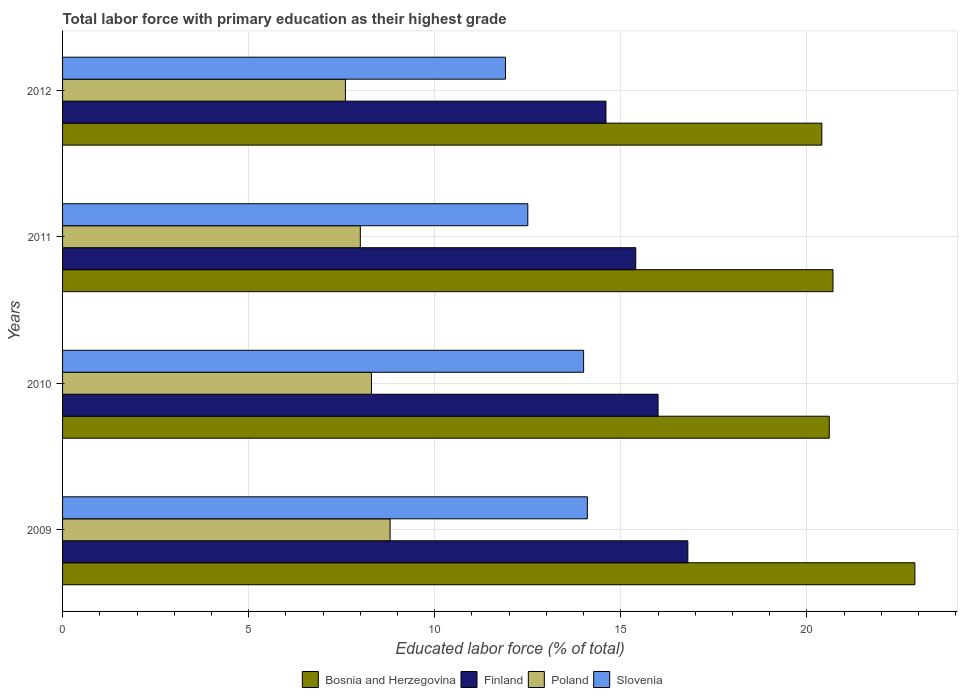Are the number of bars per tick equal to the number of legend labels?
Provide a succinct answer. Yes. What is the label of the 1st group of bars from the top?
Provide a short and direct response. 2012. In how many cases, is the number of bars for a given year not equal to the number of legend labels?
Your answer should be very brief. 0. Across all years, what is the maximum percentage of total labor force with primary education in Slovenia?
Give a very brief answer. 14.1. Across all years, what is the minimum percentage of total labor force with primary education in Bosnia and Herzegovina?
Ensure brevity in your answer.  20.4. In which year was the percentage of total labor force with primary education in Poland maximum?
Provide a short and direct response. 2009. What is the total percentage of total labor force with primary education in Finland in the graph?
Offer a very short reply. 62.8. What is the difference between the percentage of total labor force with primary education in Slovenia in 2009 and the percentage of total labor force with primary education in Finland in 2011?
Ensure brevity in your answer.  -1.3. What is the average percentage of total labor force with primary education in Slovenia per year?
Your response must be concise. 13.12. In the year 2012, what is the difference between the percentage of total labor force with primary education in Slovenia and percentage of total labor force with primary education in Bosnia and Herzegovina?
Offer a terse response. -8.5. In how many years, is the percentage of total labor force with primary education in Slovenia greater than 14 %?
Your response must be concise. 1. What is the ratio of the percentage of total labor force with primary education in Finland in 2009 to that in 2010?
Ensure brevity in your answer.  1.05. What is the difference between the highest and the second highest percentage of total labor force with primary education in Poland?
Ensure brevity in your answer.  0.5. What is the difference between the highest and the lowest percentage of total labor force with primary education in Poland?
Make the answer very short. 1.2. In how many years, is the percentage of total labor force with primary education in Bosnia and Herzegovina greater than the average percentage of total labor force with primary education in Bosnia and Herzegovina taken over all years?
Offer a very short reply. 1. Is it the case that in every year, the sum of the percentage of total labor force with primary education in Poland and percentage of total labor force with primary education in Bosnia and Herzegovina is greater than the sum of percentage of total labor force with primary education in Finland and percentage of total labor force with primary education in Slovenia?
Keep it short and to the point. No. What does the 1st bar from the top in 2009 represents?
Your response must be concise. Slovenia. What does the 3rd bar from the bottom in 2012 represents?
Give a very brief answer. Poland. How many bars are there?
Ensure brevity in your answer.  16. Are all the bars in the graph horizontal?
Your response must be concise. Yes. How many years are there in the graph?
Provide a succinct answer. 4. Does the graph contain any zero values?
Your answer should be compact. No. Does the graph contain grids?
Offer a terse response. Yes. What is the title of the graph?
Offer a terse response. Total labor force with primary education as their highest grade. What is the label or title of the X-axis?
Offer a very short reply. Educated labor force (% of total). What is the label or title of the Y-axis?
Offer a terse response. Years. What is the Educated labor force (% of total) of Bosnia and Herzegovina in 2009?
Your answer should be compact. 22.9. What is the Educated labor force (% of total) of Finland in 2009?
Your answer should be very brief. 16.8. What is the Educated labor force (% of total) of Poland in 2009?
Offer a terse response. 8.8. What is the Educated labor force (% of total) in Slovenia in 2009?
Keep it short and to the point. 14.1. What is the Educated labor force (% of total) of Bosnia and Herzegovina in 2010?
Ensure brevity in your answer.  20.6. What is the Educated labor force (% of total) of Poland in 2010?
Keep it short and to the point. 8.3. What is the Educated labor force (% of total) in Bosnia and Herzegovina in 2011?
Offer a terse response. 20.7. What is the Educated labor force (% of total) in Finland in 2011?
Your response must be concise. 15.4. What is the Educated labor force (% of total) of Bosnia and Herzegovina in 2012?
Your answer should be compact. 20.4. What is the Educated labor force (% of total) of Finland in 2012?
Give a very brief answer. 14.6. What is the Educated labor force (% of total) of Poland in 2012?
Make the answer very short. 7.6. What is the Educated labor force (% of total) of Slovenia in 2012?
Your answer should be very brief. 11.9. Across all years, what is the maximum Educated labor force (% of total) in Bosnia and Herzegovina?
Offer a very short reply. 22.9. Across all years, what is the maximum Educated labor force (% of total) of Finland?
Ensure brevity in your answer.  16.8. Across all years, what is the maximum Educated labor force (% of total) of Poland?
Your response must be concise. 8.8. Across all years, what is the maximum Educated labor force (% of total) of Slovenia?
Offer a very short reply. 14.1. Across all years, what is the minimum Educated labor force (% of total) in Bosnia and Herzegovina?
Your answer should be very brief. 20.4. Across all years, what is the minimum Educated labor force (% of total) of Finland?
Your answer should be very brief. 14.6. Across all years, what is the minimum Educated labor force (% of total) of Poland?
Give a very brief answer. 7.6. Across all years, what is the minimum Educated labor force (% of total) in Slovenia?
Give a very brief answer. 11.9. What is the total Educated labor force (% of total) of Bosnia and Herzegovina in the graph?
Your answer should be very brief. 84.6. What is the total Educated labor force (% of total) in Finland in the graph?
Your answer should be very brief. 62.8. What is the total Educated labor force (% of total) in Poland in the graph?
Keep it short and to the point. 32.7. What is the total Educated labor force (% of total) of Slovenia in the graph?
Provide a short and direct response. 52.5. What is the difference between the Educated labor force (% of total) in Bosnia and Herzegovina in 2009 and that in 2010?
Your answer should be very brief. 2.3. What is the difference between the Educated labor force (% of total) in Finland in 2009 and that in 2010?
Give a very brief answer. 0.8. What is the difference between the Educated labor force (% of total) in Poland in 2009 and that in 2010?
Make the answer very short. 0.5. What is the difference between the Educated labor force (% of total) in Slovenia in 2009 and that in 2010?
Your answer should be compact. 0.1. What is the difference between the Educated labor force (% of total) in Bosnia and Herzegovina in 2009 and that in 2011?
Your answer should be very brief. 2.2. What is the difference between the Educated labor force (% of total) of Poland in 2009 and that in 2011?
Your response must be concise. 0.8. What is the difference between the Educated labor force (% of total) of Slovenia in 2009 and that in 2011?
Provide a succinct answer. 1.6. What is the difference between the Educated labor force (% of total) in Poland in 2009 and that in 2012?
Offer a very short reply. 1.2. What is the difference between the Educated labor force (% of total) in Finland in 2010 and that in 2011?
Give a very brief answer. 0.6. What is the difference between the Educated labor force (% of total) of Poland in 2010 and that in 2011?
Make the answer very short. 0.3. What is the difference between the Educated labor force (% of total) in Poland in 2010 and that in 2012?
Provide a succinct answer. 0.7. What is the difference between the Educated labor force (% of total) of Finland in 2011 and that in 2012?
Ensure brevity in your answer.  0.8. What is the difference between the Educated labor force (% of total) of Bosnia and Herzegovina in 2009 and the Educated labor force (% of total) of Finland in 2010?
Ensure brevity in your answer.  6.9. What is the difference between the Educated labor force (% of total) of Bosnia and Herzegovina in 2009 and the Educated labor force (% of total) of Slovenia in 2010?
Make the answer very short. 8.9. What is the difference between the Educated labor force (% of total) in Finland in 2009 and the Educated labor force (% of total) in Poland in 2010?
Offer a very short reply. 8.5. What is the difference between the Educated labor force (% of total) in Poland in 2009 and the Educated labor force (% of total) in Slovenia in 2010?
Your answer should be compact. -5.2. What is the difference between the Educated labor force (% of total) in Bosnia and Herzegovina in 2009 and the Educated labor force (% of total) in Finland in 2011?
Offer a very short reply. 7.5. What is the difference between the Educated labor force (% of total) of Bosnia and Herzegovina in 2009 and the Educated labor force (% of total) of Poland in 2011?
Your response must be concise. 14.9. What is the difference between the Educated labor force (% of total) of Finland in 2009 and the Educated labor force (% of total) of Slovenia in 2011?
Keep it short and to the point. 4.3. What is the difference between the Educated labor force (% of total) of Bosnia and Herzegovina in 2009 and the Educated labor force (% of total) of Finland in 2012?
Your answer should be compact. 8.3. What is the difference between the Educated labor force (% of total) in Bosnia and Herzegovina in 2010 and the Educated labor force (% of total) in Finland in 2011?
Your answer should be compact. 5.2. What is the difference between the Educated labor force (% of total) of Bosnia and Herzegovina in 2010 and the Educated labor force (% of total) of Poland in 2011?
Ensure brevity in your answer.  12.6. What is the difference between the Educated labor force (% of total) in Bosnia and Herzegovina in 2010 and the Educated labor force (% of total) in Finland in 2012?
Provide a succinct answer. 6. What is the difference between the Educated labor force (% of total) of Bosnia and Herzegovina in 2010 and the Educated labor force (% of total) of Poland in 2012?
Keep it short and to the point. 13. What is the difference between the Educated labor force (% of total) of Finland in 2010 and the Educated labor force (% of total) of Poland in 2012?
Offer a very short reply. 8.4. What is the difference between the Educated labor force (% of total) in Bosnia and Herzegovina in 2011 and the Educated labor force (% of total) in Finland in 2012?
Make the answer very short. 6.1. What is the difference between the Educated labor force (% of total) of Bosnia and Herzegovina in 2011 and the Educated labor force (% of total) of Slovenia in 2012?
Ensure brevity in your answer.  8.8. What is the difference between the Educated labor force (% of total) of Finland in 2011 and the Educated labor force (% of total) of Slovenia in 2012?
Your answer should be very brief. 3.5. What is the difference between the Educated labor force (% of total) of Poland in 2011 and the Educated labor force (% of total) of Slovenia in 2012?
Your answer should be very brief. -3.9. What is the average Educated labor force (% of total) of Bosnia and Herzegovina per year?
Give a very brief answer. 21.15. What is the average Educated labor force (% of total) of Finland per year?
Keep it short and to the point. 15.7. What is the average Educated labor force (% of total) of Poland per year?
Provide a succinct answer. 8.18. What is the average Educated labor force (% of total) of Slovenia per year?
Your response must be concise. 13.12. In the year 2009, what is the difference between the Educated labor force (% of total) in Bosnia and Herzegovina and Educated labor force (% of total) in Finland?
Offer a very short reply. 6.1. In the year 2009, what is the difference between the Educated labor force (% of total) in Bosnia and Herzegovina and Educated labor force (% of total) in Slovenia?
Offer a terse response. 8.8. In the year 2009, what is the difference between the Educated labor force (% of total) of Finland and Educated labor force (% of total) of Poland?
Make the answer very short. 8. In the year 2009, what is the difference between the Educated labor force (% of total) of Finland and Educated labor force (% of total) of Slovenia?
Give a very brief answer. 2.7. In the year 2009, what is the difference between the Educated labor force (% of total) in Poland and Educated labor force (% of total) in Slovenia?
Keep it short and to the point. -5.3. In the year 2010, what is the difference between the Educated labor force (% of total) in Bosnia and Herzegovina and Educated labor force (% of total) in Finland?
Your response must be concise. 4.6. In the year 2010, what is the difference between the Educated labor force (% of total) of Bosnia and Herzegovina and Educated labor force (% of total) of Poland?
Your answer should be very brief. 12.3. In the year 2010, what is the difference between the Educated labor force (% of total) of Bosnia and Herzegovina and Educated labor force (% of total) of Slovenia?
Make the answer very short. 6.6. In the year 2010, what is the difference between the Educated labor force (% of total) of Finland and Educated labor force (% of total) of Poland?
Your answer should be very brief. 7.7. In the year 2010, what is the difference between the Educated labor force (% of total) in Poland and Educated labor force (% of total) in Slovenia?
Offer a terse response. -5.7. In the year 2011, what is the difference between the Educated labor force (% of total) of Bosnia and Herzegovina and Educated labor force (% of total) of Finland?
Make the answer very short. 5.3. In the year 2011, what is the difference between the Educated labor force (% of total) in Bosnia and Herzegovina and Educated labor force (% of total) in Poland?
Your response must be concise. 12.7. In the year 2011, what is the difference between the Educated labor force (% of total) in Bosnia and Herzegovina and Educated labor force (% of total) in Slovenia?
Your answer should be compact. 8.2. In the year 2011, what is the difference between the Educated labor force (% of total) in Poland and Educated labor force (% of total) in Slovenia?
Give a very brief answer. -4.5. In the year 2012, what is the difference between the Educated labor force (% of total) in Finland and Educated labor force (% of total) in Poland?
Provide a short and direct response. 7. In the year 2012, what is the difference between the Educated labor force (% of total) in Finland and Educated labor force (% of total) in Slovenia?
Offer a very short reply. 2.7. In the year 2012, what is the difference between the Educated labor force (% of total) of Poland and Educated labor force (% of total) of Slovenia?
Your answer should be very brief. -4.3. What is the ratio of the Educated labor force (% of total) of Bosnia and Herzegovina in 2009 to that in 2010?
Your answer should be very brief. 1.11. What is the ratio of the Educated labor force (% of total) in Poland in 2009 to that in 2010?
Ensure brevity in your answer.  1.06. What is the ratio of the Educated labor force (% of total) in Slovenia in 2009 to that in 2010?
Your answer should be compact. 1.01. What is the ratio of the Educated labor force (% of total) in Bosnia and Herzegovina in 2009 to that in 2011?
Keep it short and to the point. 1.11. What is the ratio of the Educated labor force (% of total) of Slovenia in 2009 to that in 2011?
Offer a terse response. 1.13. What is the ratio of the Educated labor force (% of total) in Bosnia and Herzegovina in 2009 to that in 2012?
Ensure brevity in your answer.  1.12. What is the ratio of the Educated labor force (% of total) in Finland in 2009 to that in 2012?
Your response must be concise. 1.15. What is the ratio of the Educated labor force (% of total) of Poland in 2009 to that in 2012?
Give a very brief answer. 1.16. What is the ratio of the Educated labor force (% of total) in Slovenia in 2009 to that in 2012?
Keep it short and to the point. 1.18. What is the ratio of the Educated labor force (% of total) of Finland in 2010 to that in 2011?
Ensure brevity in your answer.  1.04. What is the ratio of the Educated labor force (% of total) of Poland in 2010 to that in 2011?
Offer a terse response. 1.04. What is the ratio of the Educated labor force (% of total) of Slovenia in 2010 to that in 2011?
Provide a short and direct response. 1.12. What is the ratio of the Educated labor force (% of total) in Bosnia and Herzegovina in 2010 to that in 2012?
Give a very brief answer. 1.01. What is the ratio of the Educated labor force (% of total) of Finland in 2010 to that in 2012?
Your answer should be compact. 1.1. What is the ratio of the Educated labor force (% of total) of Poland in 2010 to that in 2012?
Your response must be concise. 1.09. What is the ratio of the Educated labor force (% of total) in Slovenia in 2010 to that in 2012?
Your answer should be compact. 1.18. What is the ratio of the Educated labor force (% of total) of Bosnia and Herzegovina in 2011 to that in 2012?
Make the answer very short. 1.01. What is the ratio of the Educated labor force (% of total) in Finland in 2011 to that in 2012?
Ensure brevity in your answer.  1.05. What is the ratio of the Educated labor force (% of total) in Poland in 2011 to that in 2012?
Ensure brevity in your answer.  1.05. What is the ratio of the Educated labor force (% of total) in Slovenia in 2011 to that in 2012?
Offer a very short reply. 1.05. What is the difference between the highest and the second highest Educated labor force (% of total) of Bosnia and Herzegovina?
Ensure brevity in your answer.  2.2. What is the difference between the highest and the second highest Educated labor force (% of total) in Finland?
Keep it short and to the point. 0.8. What is the difference between the highest and the second highest Educated labor force (% of total) of Poland?
Provide a short and direct response. 0.5. What is the difference between the highest and the second highest Educated labor force (% of total) in Slovenia?
Your response must be concise. 0.1. What is the difference between the highest and the lowest Educated labor force (% of total) of Finland?
Provide a succinct answer. 2.2. 